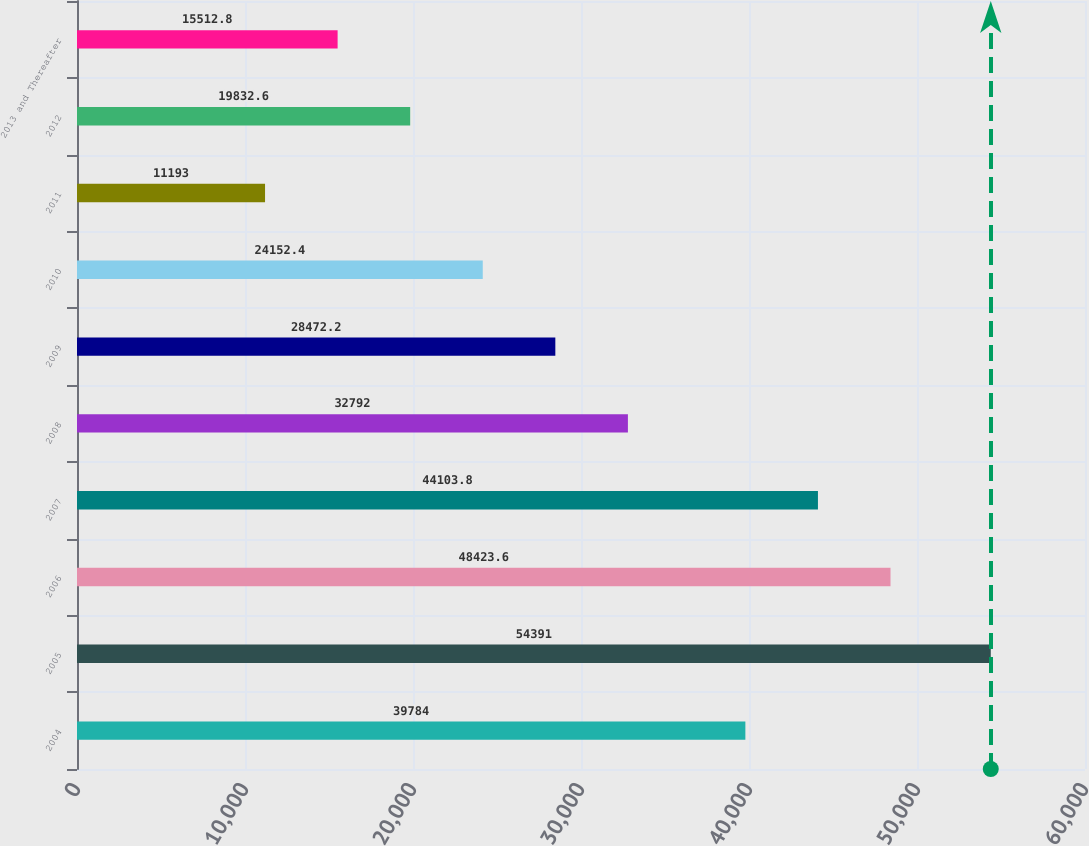Convert chart. <chart><loc_0><loc_0><loc_500><loc_500><bar_chart><fcel>2004<fcel>2005<fcel>2006<fcel>2007<fcel>2008<fcel>2009<fcel>2010<fcel>2011<fcel>2012<fcel>2013 and Thereafter<nl><fcel>39784<fcel>54391<fcel>48423.6<fcel>44103.8<fcel>32792<fcel>28472.2<fcel>24152.4<fcel>11193<fcel>19832.6<fcel>15512.8<nl></chart> 